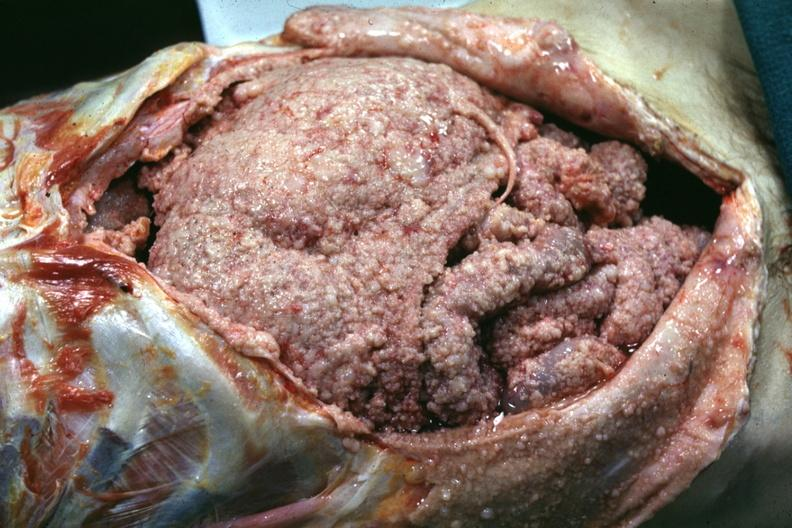where is this area in the body?
Answer the question using a single word or phrase. Abdomen 